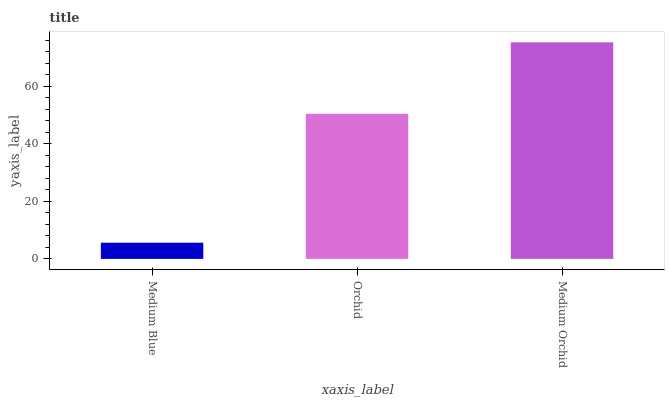Is Medium Blue the minimum?
Answer yes or no. Yes. Is Medium Orchid the maximum?
Answer yes or no. Yes. Is Orchid the minimum?
Answer yes or no. No. Is Orchid the maximum?
Answer yes or no. No. Is Orchid greater than Medium Blue?
Answer yes or no. Yes. Is Medium Blue less than Orchid?
Answer yes or no. Yes. Is Medium Blue greater than Orchid?
Answer yes or no. No. Is Orchid less than Medium Blue?
Answer yes or no. No. Is Orchid the high median?
Answer yes or no. Yes. Is Orchid the low median?
Answer yes or no. Yes. Is Medium Orchid the high median?
Answer yes or no. No. Is Medium Orchid the low median?
Answer yes or no. No. 